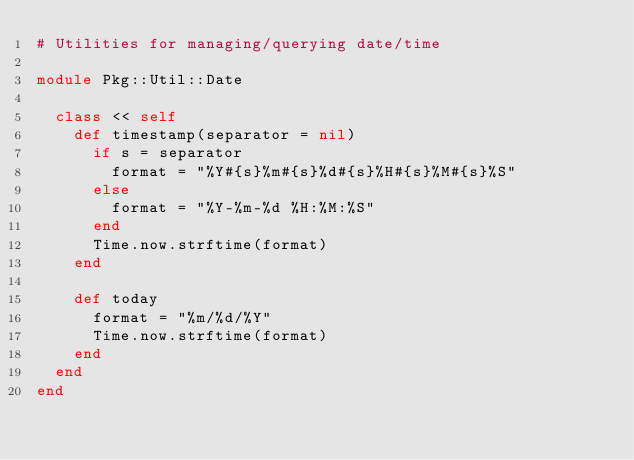<code> <loc_0><loc_0><loc_500><loc_500><_Ruby_># Utilities for managing/querying date/time

module Pkg::Util::Date

  class << self
    def timestamp(separator = nil)
      if s = separator
        format = "%Y#{s}%m#{s}%d#{s}%H#{s}%M#{s}%S"
      else
        format = "%Y-%m-%d %H:%M:%S"
      end
      Time.now.strftime(format)
    end

    def today
      format = "%m/%d/%Y"
      Time.now.strftime(format)
    end
  end
end
</code> 